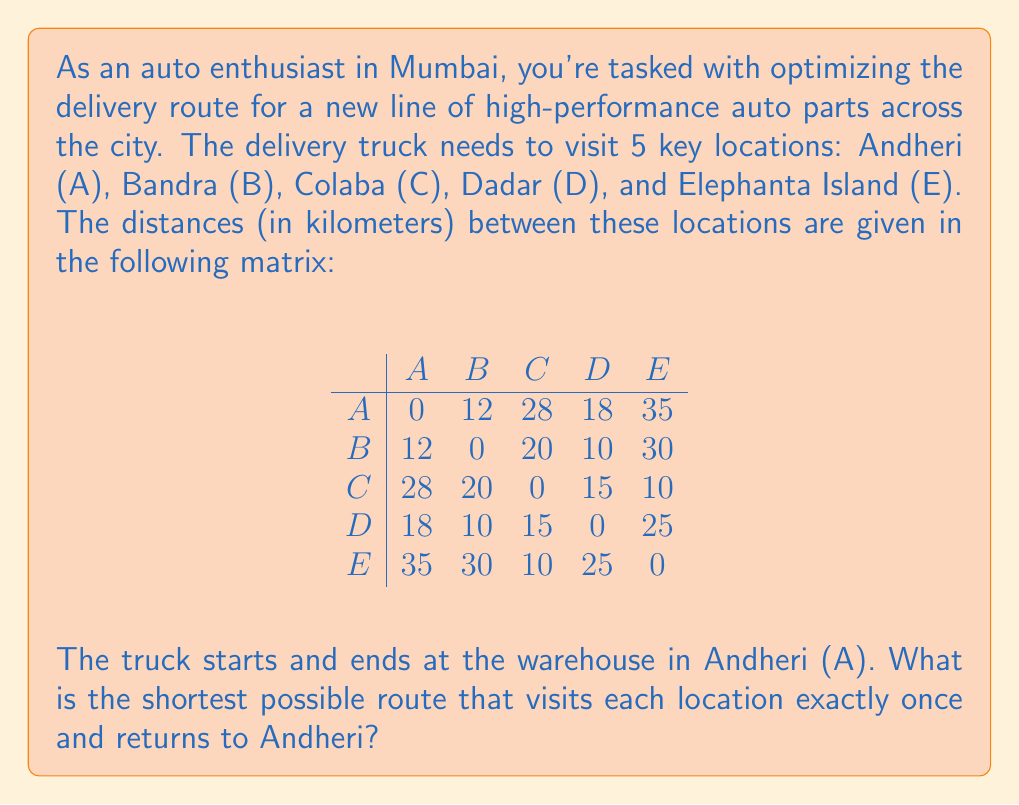Could you help me with this problem? To solve this problem, we need to use the Traveling Salesman Problem (TSP) approach. Given the small number of locations, we can use the brute force method to find the optimal solution.

Step 1: List all possible permutations of the locations B, C, D, and E.
There are 4! = 24 possible permutations.

Step 2: For each permutation, calculate the total distance of the route, including the start and end at A.

Step 3: Find the permutation with the minimum total distance.

Let's calculate a few examples:

1. A-B-C-D-E-A: 
   $12 + 20 + 15 + 25 + 35 = 107$ km

2. A-B-C-E-D-A: 
   $12 + 20 + 10 + 25 + 18 = 85$ km

3. A-C-B-D-E-A: 
   $28 + 20 + 10 + 25 + 35 = 118$ km

After calculating all 24 permutations, we find that the shortest route is:

A-B-D-C-E-A

Step 4: Calculate the total distance of the optimal route:
A to B: 12 km
B to D: 10 km
D to C: 15 km
C to E: 10 km
E to A: 35 km

Total distance: $12 + 10 + 15 + 10 + 35 = 82$ km

Therefore, the shortest possible route that visits each location exactly once and returns to Andheri is A-B-D-C-E-A, with a total distance of 82 km.
Answer: A-B-D-C-E-A, 82 km 